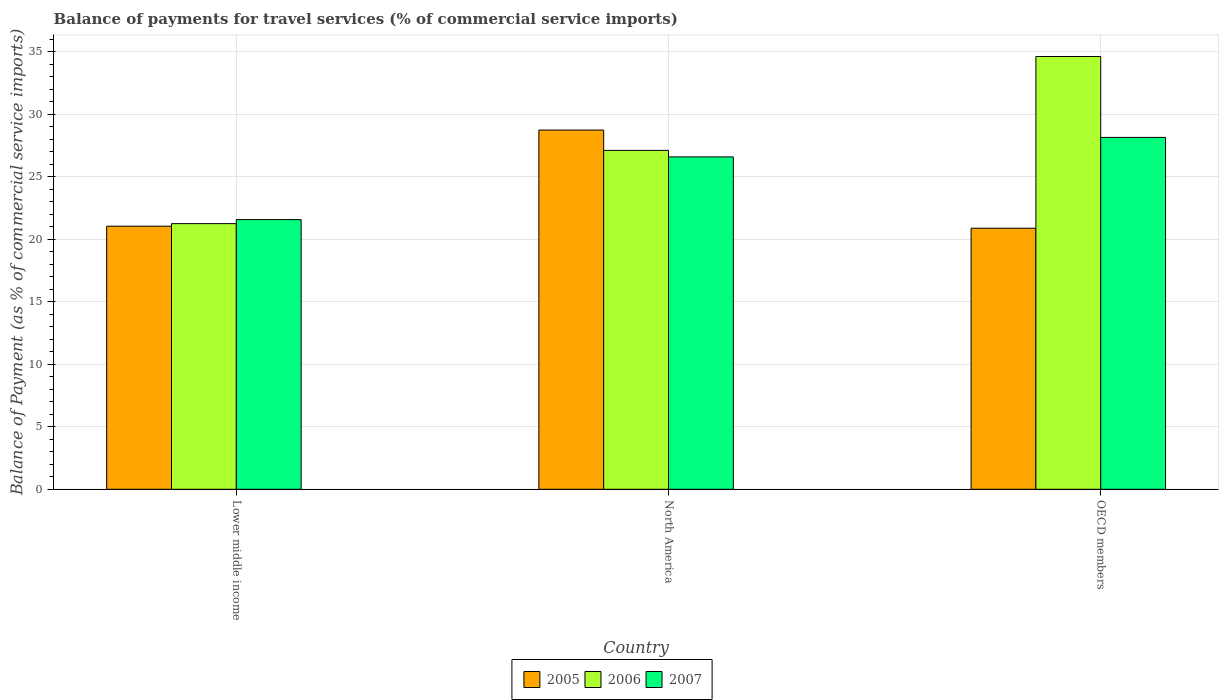How many different coloured bars are there?
Keep it short and to the point. 3. How many bars are there on the 2nd tick from the left?
Your response must be concise. 3. In how many cases, is the number of bars for a given country not equal to the number of legend labels?
Make the answer very short. 0. What is the balance of payments for travel services in 2006 in OECD members?
Offer a terse response. 34.61. Across all countries, what is the maximum balance of payments for travel services in 2007?
Keep it short and to the point. 28.14. Across all countries, what is the minimum balance of payments for travel services in 2006?
Your answer should be compact. 21.25. In which country was the balance of payments for travel services in 2007 minimum?
Offer a very short reply. Lower middle income. What is the total balance of payments for travel services in 2006 in the graph?
Provide a short and direct response. 82.96. What is the difference between the balance of payments for travel services in 2007 in Lower middle income and that in OECD members?
Offer a very short reply. -6.57. What is the difference between the balance of payments for travel services in 2006 in Lower middle income and the balance of payments for travel services in 2007 in North America?
Ensure brevity in your answer.  -5.34. What is the average balance of payments for travel services in 2006 per country?
Offer a terse response. 27.65. What is the difference between the balance of payments for travel services of/in 2006 and balance of payments for travel services of/in 2007 in OECD members?
Offer a very short reply. 6.47. In how many countries, is the balance of payments for travel services in 2006 greater than 1 %?
Give a very brief answer. 3. What is the ratio of the balance of payments for travel services in 2007 in Lower middle income to that in North America?
Your response must be concise. 0.81. Is the balance of payments for travel services in 2005 in Lower middle income less than that in North America?
Provide a succinct answer. Yes. Is the difference between the balance of payments for travel services in 2006 in Lower middle income and North America greater than the difference between the balance of payments for travel services in 2007 in Lower middle income and North America?
Provide a succinct answer. No. What is the difference between the highest and the second highest balance of payments for travel services in 2007?
Ensure brevity in your answer.  -1.56. What is the difference between the highest and the lowest balance of payments for travel services in 2005?
Provide a succinct answer. 7.85. In how many countries, is the balance of payments for travel services in 2005 greater than the average balance of payments for travel services in 2005 taken over all countries?
Your answer should be very brief. 1. What does the 2nd bar from the left in OECD members represents?
Your response must be concise. 2006. What does the 1st bar from the right in OECD members represents?
Give a very brief answer. 2007. How many bars are there?
Keep it short and to the point. 9. How many countries are there in the graph?
Your answer should be compact. 3. Does the graph contain any zero values?
Keep it short and to the point. No. Where does the legend appear in the graph?
Make the answer very short. Bottom center. How many legend labels are there?
Your response must be concise. 3. How are the legend labels stacked?
Ensure brevity in your answer.  Horizontal. What is the title of the graph?
Give a very brief answer. Balance of payments for travel services (% of commercial service imports). What is the label or title of the X-axis?
Provide a short and direct response. Country. What is the label or title of the Y-axis?
Provide a succinct answer. Balance of Payment (as % of commercial service imports). What is the Balance of Payment (as % of commercial service imports) in 2005 in Lower middle income?
Provide a short and direct response. 21.04. What is the Balance of Payment (as % of commercial service imports) of 2006 in Lower middle income?
Offer a very short reply. 21.25. What is the Balance of Payment (as % of commercial service imports) in 2007 in Lower middle income?
Provide a short and direct response. 21.57. What is the Balance of Payment (as % of commercial service imports) in 2005 in North America?
Ensure brevity in your answer.  28.73. What is the Balance of Payment (as % of commercial service imports) in 2006 in North America?
Keep it short and to the point. 27.11. What is the Balance of Payment (as % of commercial service imports) of 2007 in North America?
Provide a short and direct response. 26.58. What is the Balance of Payment (as % of commercial service imports) of 2005 in OECD members?
Make the answer very short. 20.88. What is the Balance of Payment (as % of commercial service imports) in 2006 in OECD members?
Your answer should be very brief. 34.61. What is the Balance of Payment (as % of commercial service imports) in 2007 in OECD members?
Make the answer very short. 28.14. Across all countries, what is the maximum Balance of Payment (as % of commercial service imports) of 2005?
Give a very brief answer. 28.73. Across all countries, what is the maximum Balance of Payment (as % of commercial service imports) in 2006?
Give a very brief answer. 34.61. Across all countries, what is the maximum Balance of Payment (as % of commercial service imports) in 2007?
Ensure brevity in your answer.  28.14. Across all countries, what is the minimum Balance of Payment (as % of commercial service imports) of 2005?
Your answer should be very brief. 20.88. Across all countries, what is the minimum Balance of Payment (as % of commercial service imports) of 2006?
Ensure brevity in your answer.  21.25. Across all countries, what is the minimum Balance of Payment (as % of commercial service imports) of 2007?
Provide a short and direct response. 21.57. What is the total Balance of Payment (as % of commercial service imports) in 2005 in the graph?
Offer a terse response. 70.65. What is the total Balance of Payment (as % of commercial service imports) of 2006 in the graph?
Make the answer very short. 82.96. What is the total Balance of Payment (as % of commercial service imports) of 2007 in the graph?
Provide a succinct answer. 76.29. What is the difference between the Balance of Payment (as % of commercial service imports) of 2005 in Lower middle income and that in North America?
Give a very brief answer. -7.69. What is the difference between the Balance of Payment (as % of commercial service imports) of 2006 in Lower middle income and that in North America?
Your answer should be compact. -5.86. What is the difference between the Balance of Payment (as % of commercial service imports) of 2007 in Lower middle income and that in North America?
Your response must be concise. -5.02. What is the difference between the Balance of Payment (as % of commercial service imports) in 2005 in Lower middle income and that in OECD members?
Your answer should be compact. 0.16. What is the difference between the Balance of Payment (as % of commercial service imports) in 2006 in Lower middle income and that in OECD members?
Give a very brief answer. -13.37. What is the difference between the Balance of Payment (as % of commercial service imports) of 2007 in Lower middle income and that in OECD members?
Your answer should be compact. -6.57. What is the difference between the Balance of Payment (as % of commercial service imports) in 2005 in North America and that in OECD members?
Give a very brief answer. 7.85. What is the difference between the Balance of Payment (as % of commercial service imports) of 2006 in North America and that in OECD members?
Make the answer very short. -7.51. What is the difference between the Balance of Payment (as % of commercial service imports) of 2007 in North America and that in OECD members?
Provide a succinct answer. -1.56. What is the difference between the Balance of Payment (as % of commercial service imports) of 2005 in Lower middle income and the Balance of Payment (as % of commercial service imports) of 2006 in North America?
Offer a terse response. -6.06. What is the difference between the Balance of Payment (as % of commercial service imports) of 2005 in Lower middle income and the Balance of Payment (as % of commercial service imports) of 2007 in North America?
Offer a terse response. -5.54. What is the difference between the Balance of Payment (as % of commercial service imports) in 2006 in Lower middle income and the Balance of Payment (as % of commercial service imports) in 2007 in North America?
Offer a terse response. -5.34. What is the difference between the Balance of Payment (as % of commercial service imports) in 2005 in Lower middle income and the Balance of Payment (as % of commercial service imports) in 2006 in OECD members?
Provide a short and direct response. -13.57. What is the difference between the Balance of Payment (as % of commercial service imports) of 2005 in Lower middle income and the Balance of Payment (as % of commercial service imports) of 2007 in OECD members?
Keep it short and to the point. -7.1. What is the difference between the Balance of Payment (as % of commercial service imports) of 2006 in Lower middle income and the Balance of Payment (as % of commercial service imports) of 2007 in OECD members?
Give a very brief answer. -6.9. What is the difference between the Balance of Payment (as % of commercial service imports) of 2005 in North America and the Balance of Payment (as % of commercial service imports) of 2006 in OECD members?
Offer a very short reply. -5.88. What is the difference between the Balance of Payment (as % of commercial service imports) in 2005 in North America and the Balance of Payment (as % of commercial service imports) in 2007 in OECD members?
Give a very brief answer. 0.59. What is the difference between the Balance of Payment (as % of commercial service imports) in 2006 in North America and the Balance of Payment (as % of commercial service imports) in 2007 in OECD members?
Make the answer very short. -1.04. What is the average Balance of Payment (as % of commercial service imports) of 2005 per country?
Ensure brevity in your answer.  23.55. What is the average Balance of Payment (as % of commercial service imports) of 2006 per country?
Your answer should be compact. 27.65. What is the average Balance of Payment (as % of commercial service imports) of 2007 per country?
Provide a short and direct response. 25.43. What is the difference between the Balance of Payment (as % of commercial service imports) of 2005 and Balance of Payment (as % of commercial service imports) of 2006 in Lower middle income?
Give a very brief answer. -0.2. What is the difference between the Balance of Payment (as % of commercial service imports) of 2005 and Balance of Payment (as % of commercial service imports) of 2007 in Lower middle income?
Give a very brief answer. -0.53. What is the difference between the Balance of Payment (as % of commercial service imports) of 2006 and Balance of Payment (as % of commercial service imports) of 2007 in Lower middle income?
Provide a short and direct response. -0.32. What is the difference between the Balance of Payment (as % of commercial service imports) of 2005 and Balance of Payment (as % of commercial service imports) of 2006 in North America?
Make the answer very short. 1.63. What is the difference between the Balance of Payment (as % of commercial service imports) of 2005 and Balance of Payment (as % of commercial service imports) of 2007 in North America?
Provide a short and direct response. 2.15. What is the difference between the Balance of Payment (as % of commercial service imports) in 2006 and Balance of Payment (as % of commercial service imports) in 2007 in North America?
Provide a short and direct response. 0.52. What is the difference between the Balance of Payment (as % of commercial service imports) in 2005 and Balance of Payment (as % of commercial service imports) in 2006 in OECD members?
Offer a very short reply. -13.73. What is the difference between the Balance of Payment (as % of commercial service imports) of 2005 and Balance of Payment (as % of commercial service imports) of 2007 in OECD members?
Your answer should be very brief. -7.26. What is the difference between the Balance of Payment (as % of commercial service imports) in 2006 and Balance of Payment (as % of commercial service imports) in 2007 in OECD members?
Provide a short and direct response. 6.47. What is the ratio of the Balance of Payment (as % of commercial service imports) in 2005 in Lower middle income to that in North America?
Your answer should be compact. 0.73. What is the ratio of the Balance of Payment (as % of commercial service imports) of 2006 in Lower middle income to that in North America?
Your answer should be compact. 0.78. What is the ratio of the Balance of Payment (as % of commercial service imports) of 2007 in Lower middle income to that in North America?
Offer a very short reply. 0.81. What is the ratio of the Balance of Payment (as % of commercial service imports) of 2006 in Lower middle income to that in OECD members?
Your response must be concise. 0.61. What is the ratio of the Balance of Payment (as % of commercial service imports) in 2007 in Lower middle income to that in OECD members?
Keep it short and to the point. 0.77. What is the ratio of the Balance of Payment (as % of commercial service imports) of 2005 in North America to that in OECD members?
Make the answer very short. 1.38. What is the ratio of the Balance of Payment (as % of commercial service imports) of 2006 in North America to that in OECD members?
Offer a very short reply. 0.78. What is the ratio of the Balance of Payment (as % of commercial service imports) of 2007 in North America to that in OECD members?
Offer a very short reply. 0.94. What is the difference between the highest and the second highest Balance of Payment (as % of commercial service imports) in 2005?
Make the answer very short. 7.69. What is the difference between the highest and the second highest Balance of Payment (as % of commercial service imports) of 2006?
Keep it short and to the point. 7.51. What is the difference between the highest and the second highest Balance of Payment (as % of commercial service imports) in 2007?
Keep it short and to the point. 1.56. What is the difference between the highest and the lowest Balance of Payment (as % of commercial service imports) in 2005?
Give a very brief answer. 7.85. What is the difference between the highest and the lowest Balance of Payment (as % of commercial service imports) of 2006?
Offer a terse response. 13.37. What is the difference between the highest and the lowest Balance of Payment (as % of commercial service imports) in 2007?
Make the answer very short. 6.57. 